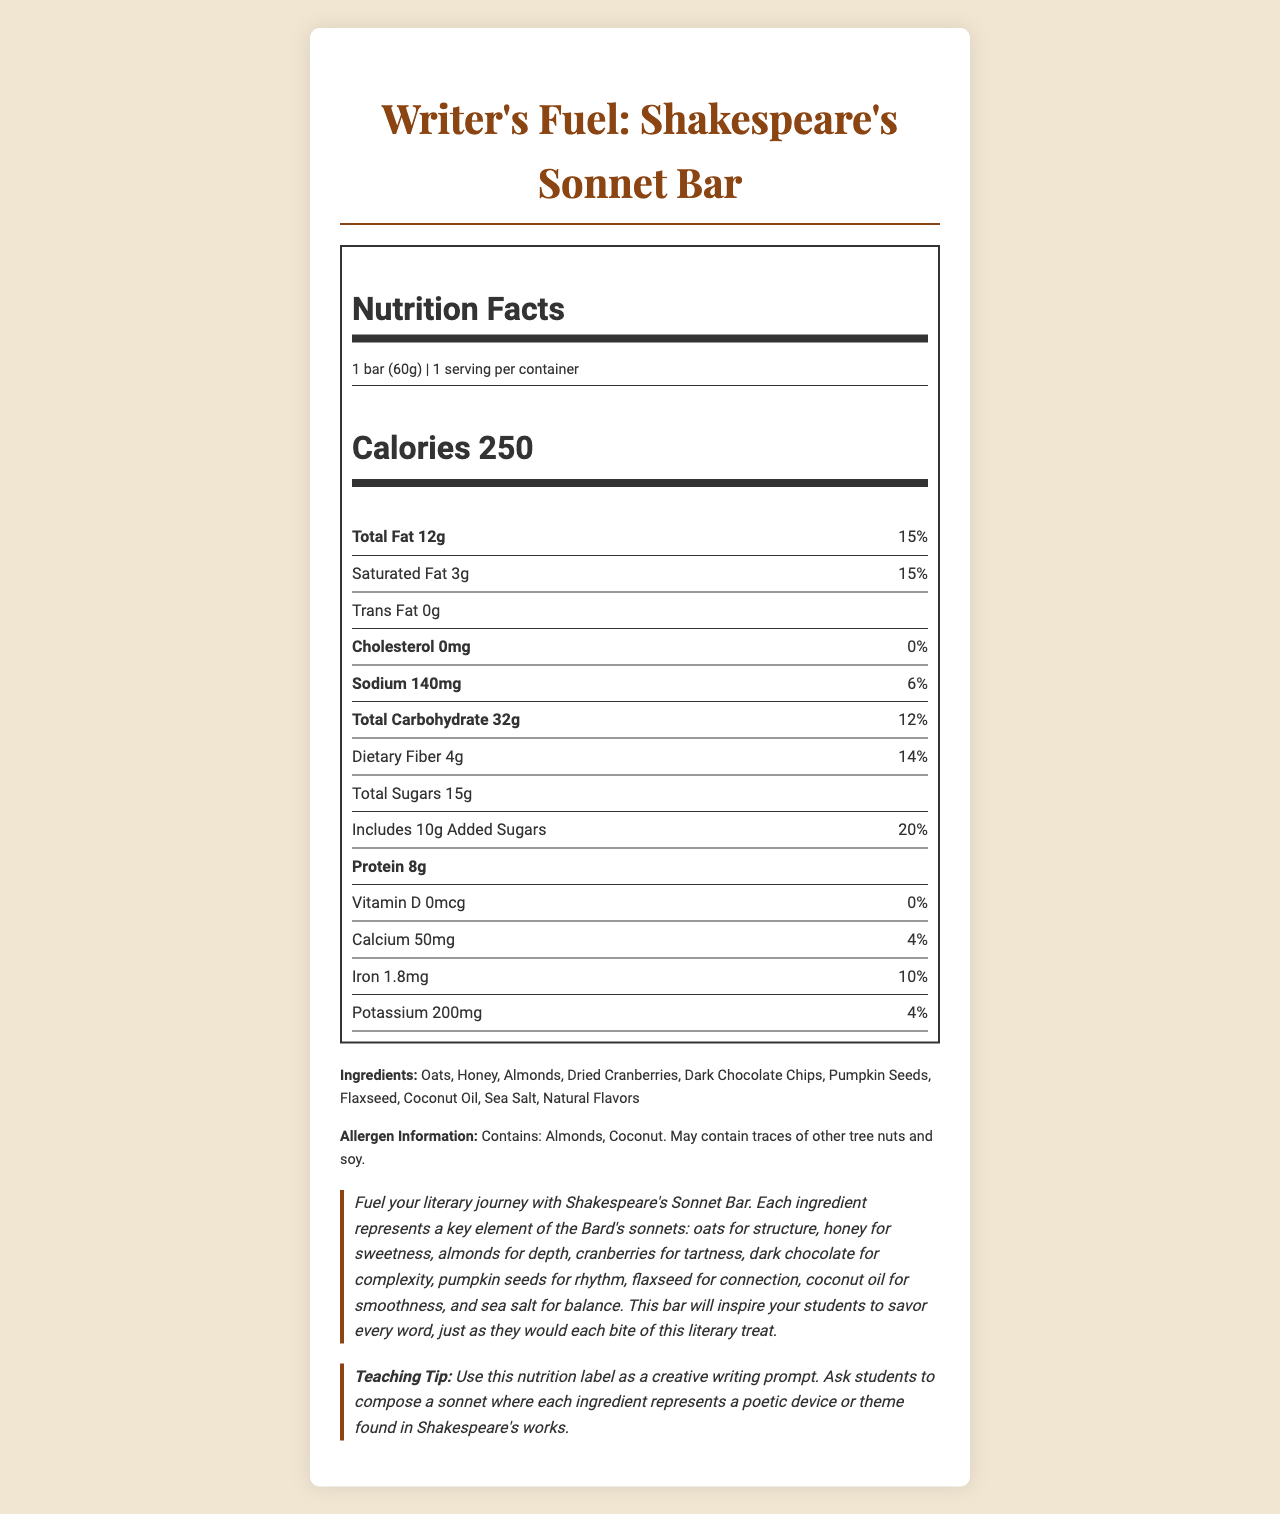what is the serving size for the "Writer's Fuel: Shakespeare's Sonnet Bar"? The serving size is listed directly under the product name at the top of the nutrition label.
Answer: 1 bar (60g) how many calories are there in one serving of the "Writer's Fuel: Shakespeare's Sonnet Bar"? The calorie content is displayed prominently in the calorie information section.
Answer: 250 calories what is the percentage of daily value for sodium in the bar? The sodium content is 140mg, and the percentage of the daily value is listed as 6% right next to it.
Answer: 6% how much protein does the "Writer's Fuel: Shakespeare's Sonnet Bar" contain? The protein amount is found in the nutrient information section and clearly states 8g.
Answer: 8g what are the main ingredients in the "Writer's Fuel: Shakespeare's Sonnet Bar"? The ingredients are listed after the allergen information in the document.
Answer: Oats, Honey, Almonds, Dried Cranberries, Dark Chocolate Chips, Pumpkin Seeds, Flaxseed, Coconut Oil, Sea Salt, Natural Flavors how much dietary fiber is in each bar? The dietary fiber content is listed under the total carbohydrate section of the nutrient information.
Answer: 4g what are the total sugars in the bar? The total sugar content is provided in the nutrient information.
Answer: 15g what allergen information is provided on the label? The allergen information is listed below the ingredients.
Answer: Contains: Almonds, Coconut. May contain traces of other tree nuts and soy. which of the following best describes the fat content of the bar?
    A. No fat
    B. Low fat
    C. Moderate fat
    D. High fat The total fat content is 12g which is 15% of the daily value, indicating moderate fat content.
Answer: C. Moderate fat which nutrient does the bar have in the lowest percent daily value? 
    i. Vitamin D 
    ii. Calcium 
    iii. Iron The bar contains 0mcg of Vitamin D, resulting in 0% of the daily value.
Answer: i. Vitamin D is the bar cholesterol-free? The nutrition label states that the cholesterol amount is 0mg with a percent daily value of 0%.
Answer: Yes is this bar suitable for a student who is allergic to soy? The allergen information mentions that the bar may contain traces of soy.
Answer: No summarize the main idea of the Nutrition Facts Label for the "Writer's Fuel: Shakespeare's Sonnet Bar". The document provides a detailed nutritional breakdown of the "Writer's Fuel: Shakespeare's Sonnet Bar," highlights its literary-themed ingredients, and includes a creative teaching tip for English teachers.
Answer: The "Writer’s Fuel: Shakespeare’s Sonnet Bar" is an energy bar designed with literary-inspired ingredients aimed at enhancing the literary journey. It combines nutritional benefits like 250 calories, 12g of total fat, 32g of carbohydrates, 8g of protein, and various vitamins and minerals. The bar includes ingredients such as oats, honey, almonds, and cranberries, and provides a unique teaching tip to use the ingredients as a creative writing prompt. who is the intended market for the "Writer's Fuel: Shakespeare's Sonnet Bar"? The document provides detailed nutritional information and a literary description but does not explicitly state the intended market.
Answer: Cannot be determined 